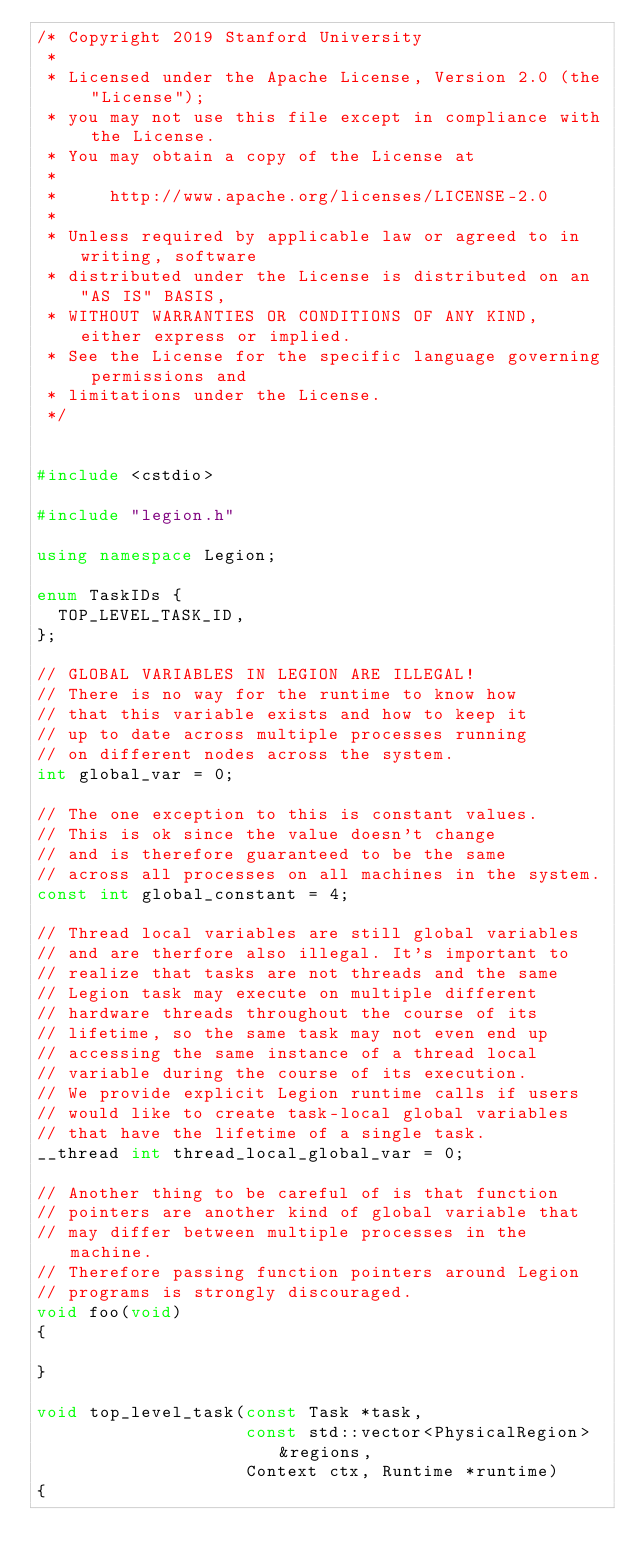Convert code to text. <code><loc_0><loc_0><loc_500><loc_500><_C++_>/* Copyright 2019 Stanford University
 *
 * Licensed under the Apache License, Version 2.0 (the "License");
 * you may not use this file except in compliance with the License.
 * You may obtain a copy of the License at
 *
 *     http://www.apache.org/licenses/LICENSE-2.0
 *
 * Unless required by applicable law or agreed to in writing, software
 * distributed under the License is distributed on an "AS IS" BASIS,
 * WITHOUT WARRANTIES OR CONDITIONS OF ANY KIND, either express or implied.
 * See the License for the specific language governing permissions and
 * limitations under the License.
 */


#include <cstdio>

#include "legion.h"

using namespace Legion;

enum TaskIDs {
  TOP_LEVEL_TASK_ID,
};

// GLOBAL VARIABLES IN LEGION ARE ILLEGAL!
// There is no way for the runtime to know how
// that this variable exists and how to keep it
// up to date across multiple processes running
// on different nodes across the system.
int global_var = 0;

// The one exception to this is constant values.
// This is ok since the value doesn't change
// and is therefore guaranteed to be the same
// across all processes on all machines in the system.
const int global_constant = 4;

// Thread local variables are still global variables
// and are therfore also illegal. It's important to
// realize that tasks are not threads and the same
// Legion task may execute on multiple different 
// hardware threads throughout the course of its
// lifetime, so the same task may not even end up
// accessing the same instance of a thread local 
// variable during the course of its execution. 
// We provide explicit Legion runtime calls if users 
// would like to create task-local global variables 
// that have the lifetime of a single task.
__thread int thread_local_global_var = 0;

// Another thing to be careful of is that function
// pointers are another kind of global variable that
// may differ between multiple processes in the machine.
// Therefore passing function pointers around Legion
// programs is strongly discouraged.
void foo(void)
{

}

void top_level_task(const Task *task,
                    const std::vector<PhysicalRegion> &regions,
                    Context ctx, Runtime *runtime)
{</code> 